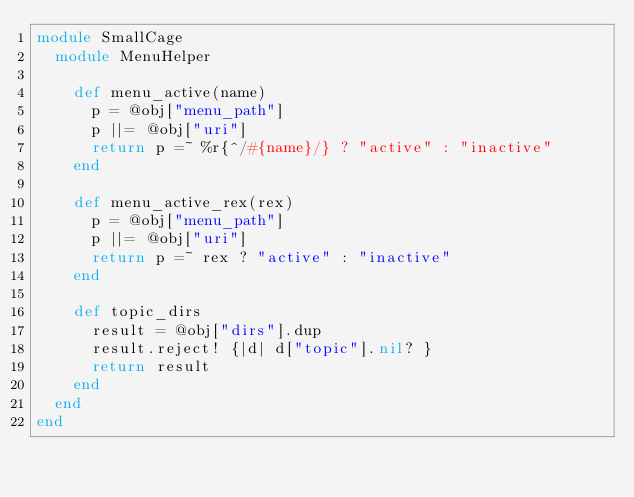Convert code to text. <code><loc_0><loc_0><loc_500><loc_500><_Ruby_>module SmallCage
  module MenuHelper

    def menu_active(name)
      p = @obj["menu_path"]
      p ||= @obj["uri"]
      return p =~ %r{^/#{name}/} ? "active" : "inactive"
    end

    def menu_active_rex(rex)
      p = @obj["menu_path"]
      p ||= @obj["uri"]
      return p =~ rex ? "active" : "inactive"
    end

    def topic_dirs
      result = @obj["dirs"].dup
      result.reject! {|d| d["topic"].nil? }
      return result
    end
  end
end
</code> 